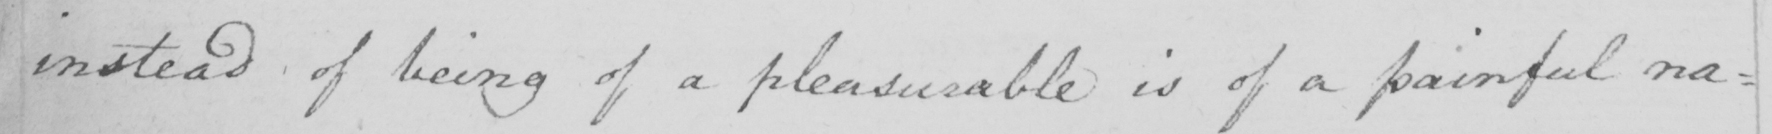Please transcribe the handwritten text in this image. instead of being of a pleasurable is of a painful na : 